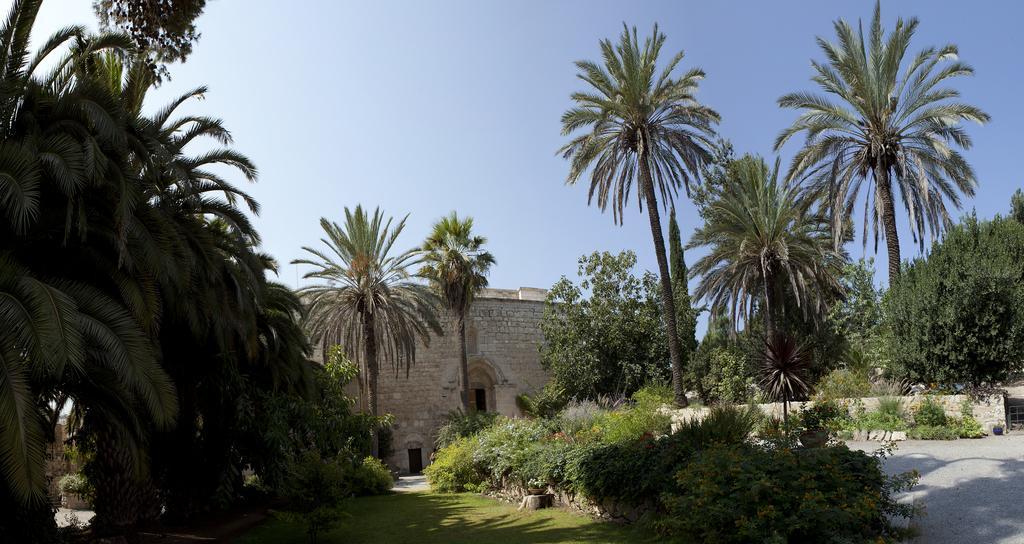How would you summarize this image in a sentence or two? In this image I can see a building ,in front the building I can see trees, bushes , grass, at the top I can see the sky. 